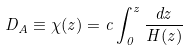<formula> <loc_0><loc_0><loc_500><loc_500>D _ { A } \equiv \chi ( z ) = c \int _ { 0 } ^ { z } { \frac { d z } { H ( z ) } }</formula> 